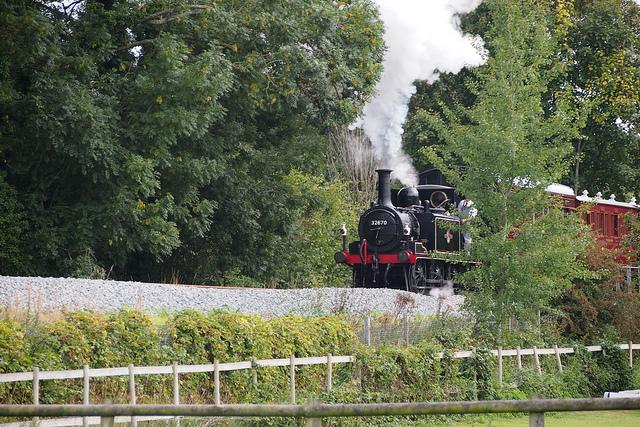Where is the steam from?
Be succinct. Train. Is the train passing through the countryside?
Give a very brief answer. Yes. How many trains?
Concise answer only. 1. What mode of transportation is in the picture?
Write a very short answer. Train. 